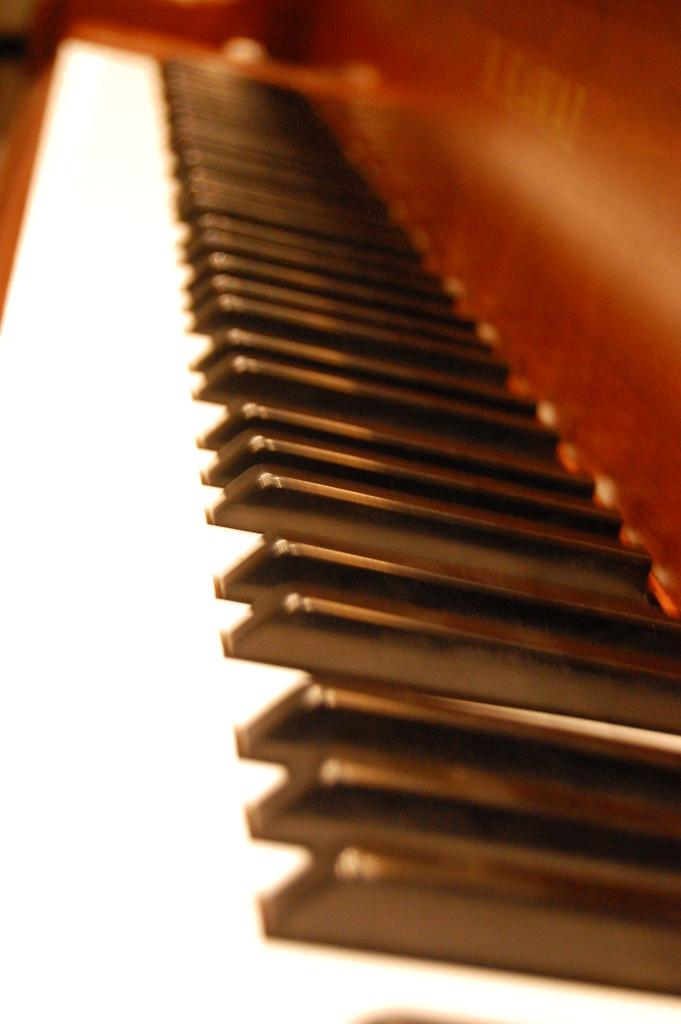What musical instrument is present in the image? There is a piano in the image. Where is the bucket located in the image? There is no bucket present in the image. How many babies are visible in the image? There are no babies present in the image. 